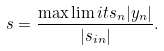Convert formula to latex. <formula><loc_0><loc_0><loc_500><loc_500>s = \frac { \max \lim i t s _ { n } | y _ { n } | } { | s _ { i n } | } .</formula> 